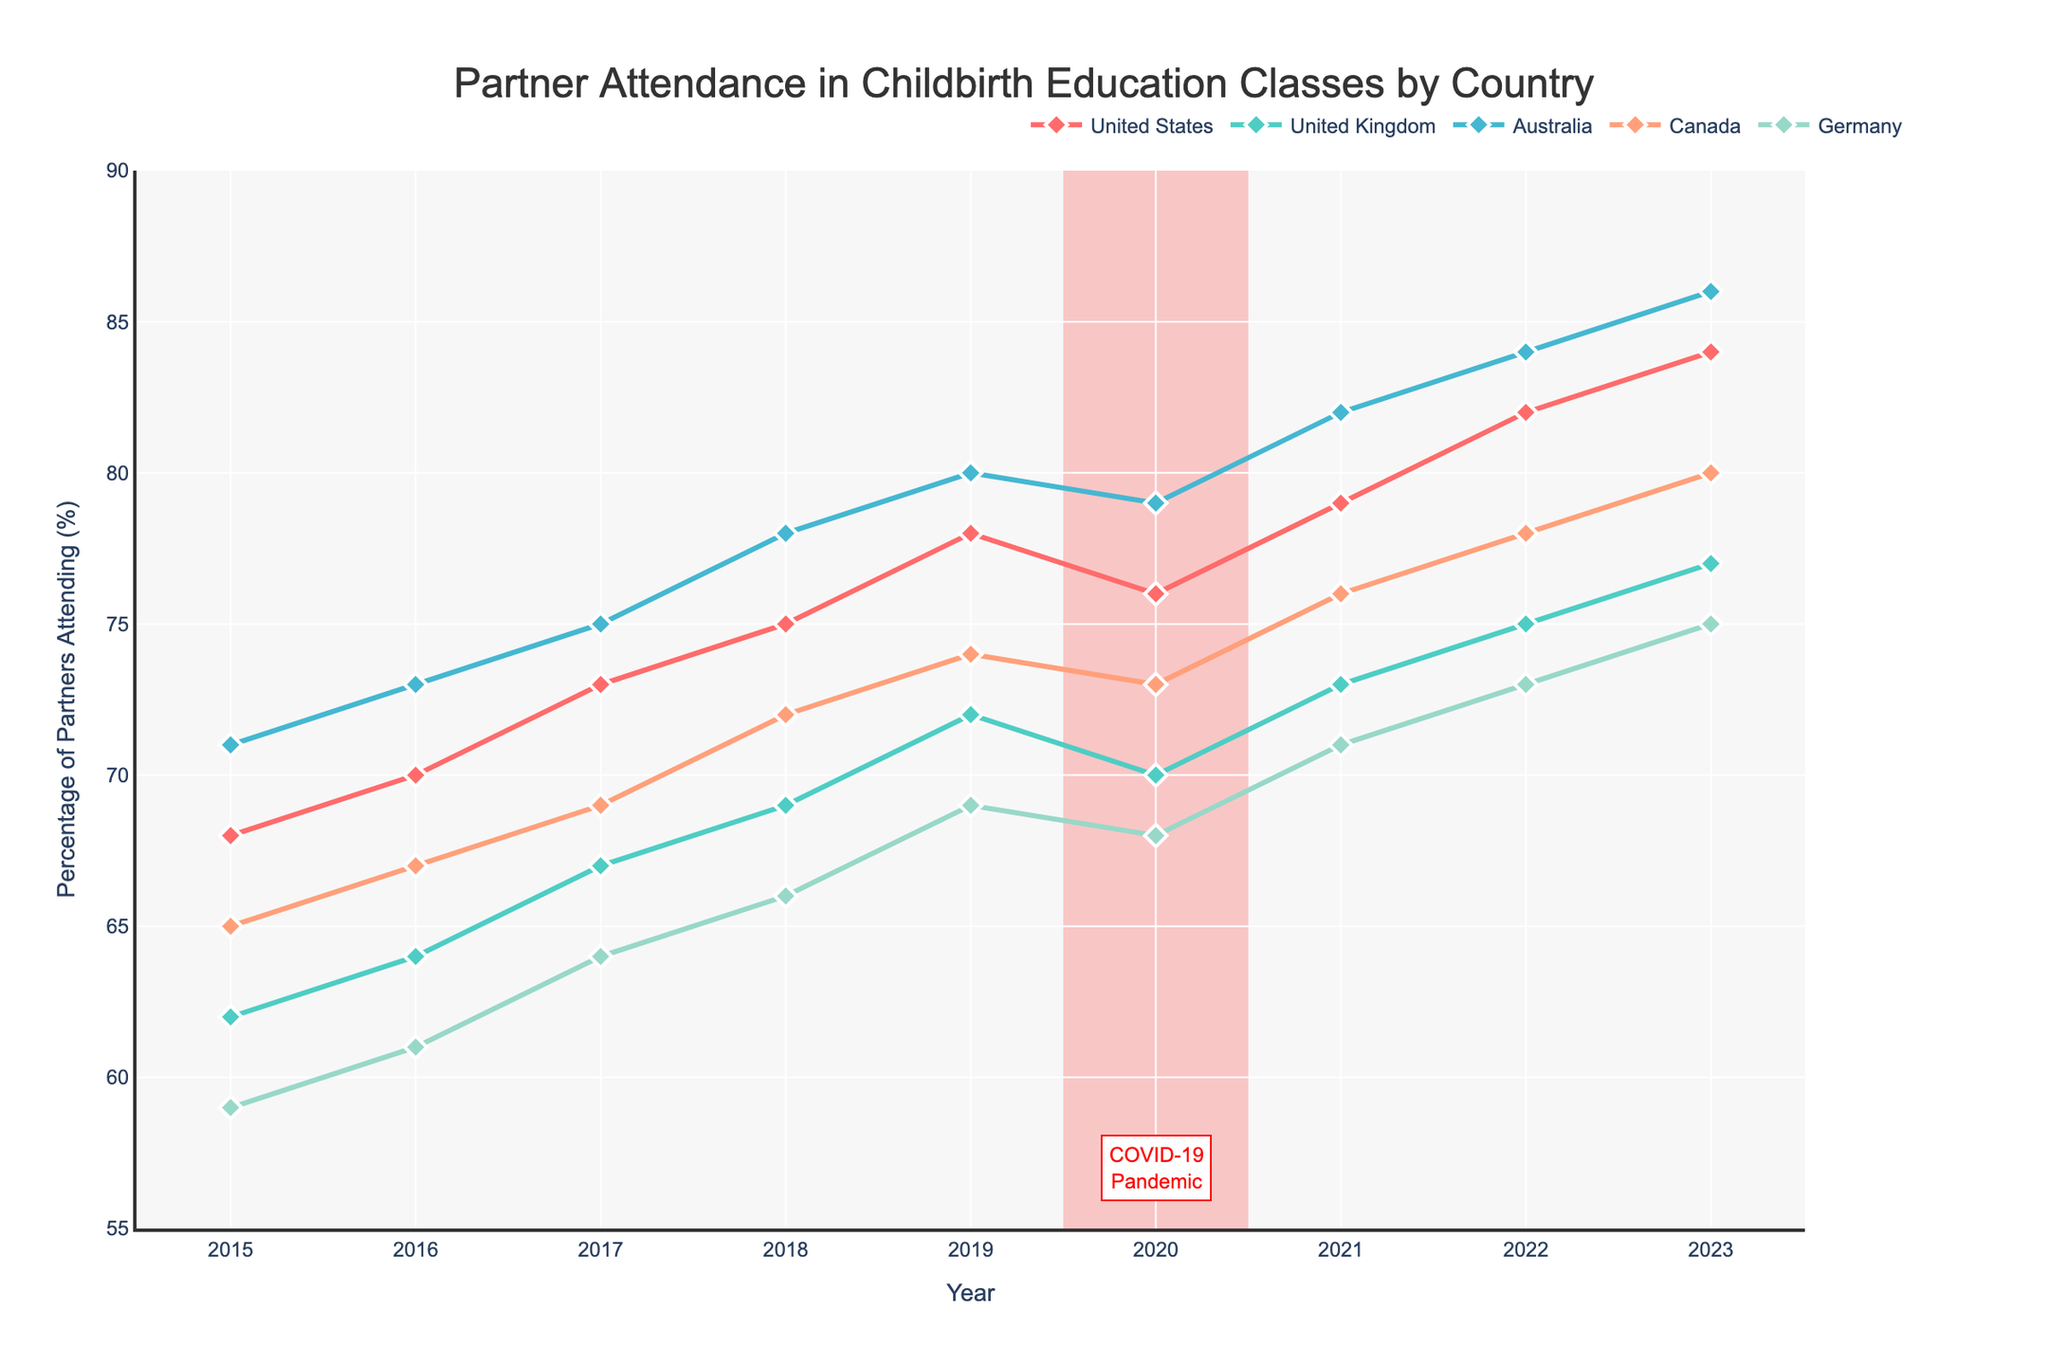What is the percentage increase in partner attendance in the United States from 2015 to 2023? First, find the percentage for 2015 (68%) and 2023 (84%). Calculate the difference which is 84 - 68 = 16%. This increase is over 8 years.
Answer: 16% Which country saw the highest attendance percentage in 2023? Based on the final data points, the highest attendance percentage in 2023 is 86% for Australia.
Answer: Australia Which year shows a decline in partner attendance for any country due to the COVID-19 pandemic? Look at the section highlighted for 2020. The United States shows a drop from 78% in 2019 to 76% in 2020.
Answer: 2020 Compare the attendance percentage in 2017 between the United Kingdom and Germany. Which one is higher? From the data, in 2017, the UK is at 67% and Germany is at 64%. Thus, the UK has a higher percentage.
Answer: United Kingdom What is the average attendance percentage for Canada from 2015 to 2023? Sum the attendance percentages for Canada from all the years and divide by the number of years (65, 67, 69, 72, 74, 73, 76, 78, 80). The sum is 654 and there are 9 years. So, 654 / 9 = 72.67%.
Answer: 72.67% Which two countries had the most similar attendance percentages in 2021? Compare the percentages for each country in 2021. The closest percentages are the UK (73%) and Germany (71%), a difference of 2%.
Answer: United Kingdom and Germany From 2017 to 2020, which country had the smallest change in partner attendance percentage? Calculate the differences for each country over these years: US (76 - 73 = 3%), UK (70 - 67 = 3%), Australia (79 - 75 = 4%), Canada (73 - 69 = 4%), Germany (68 - 64 = 4%). The smallest changes are for the US and UK, both at 3%.
Answer: United States and United Kingdom What is the difference in attendance percentages between the highest and lowest countries in 2022? In 2022, Australia has the highest (84%) and Germany the lowest (73%). The difference is 84 - 73 = 11%.
Answer: 11% How many total percentage points did Germany's attendance increase from 2015 to 2023? Subtract the percentage in 2015 (59%) from the percentage in 2023 (75%): 75 - 59 = 16%.
Answer: 16% 